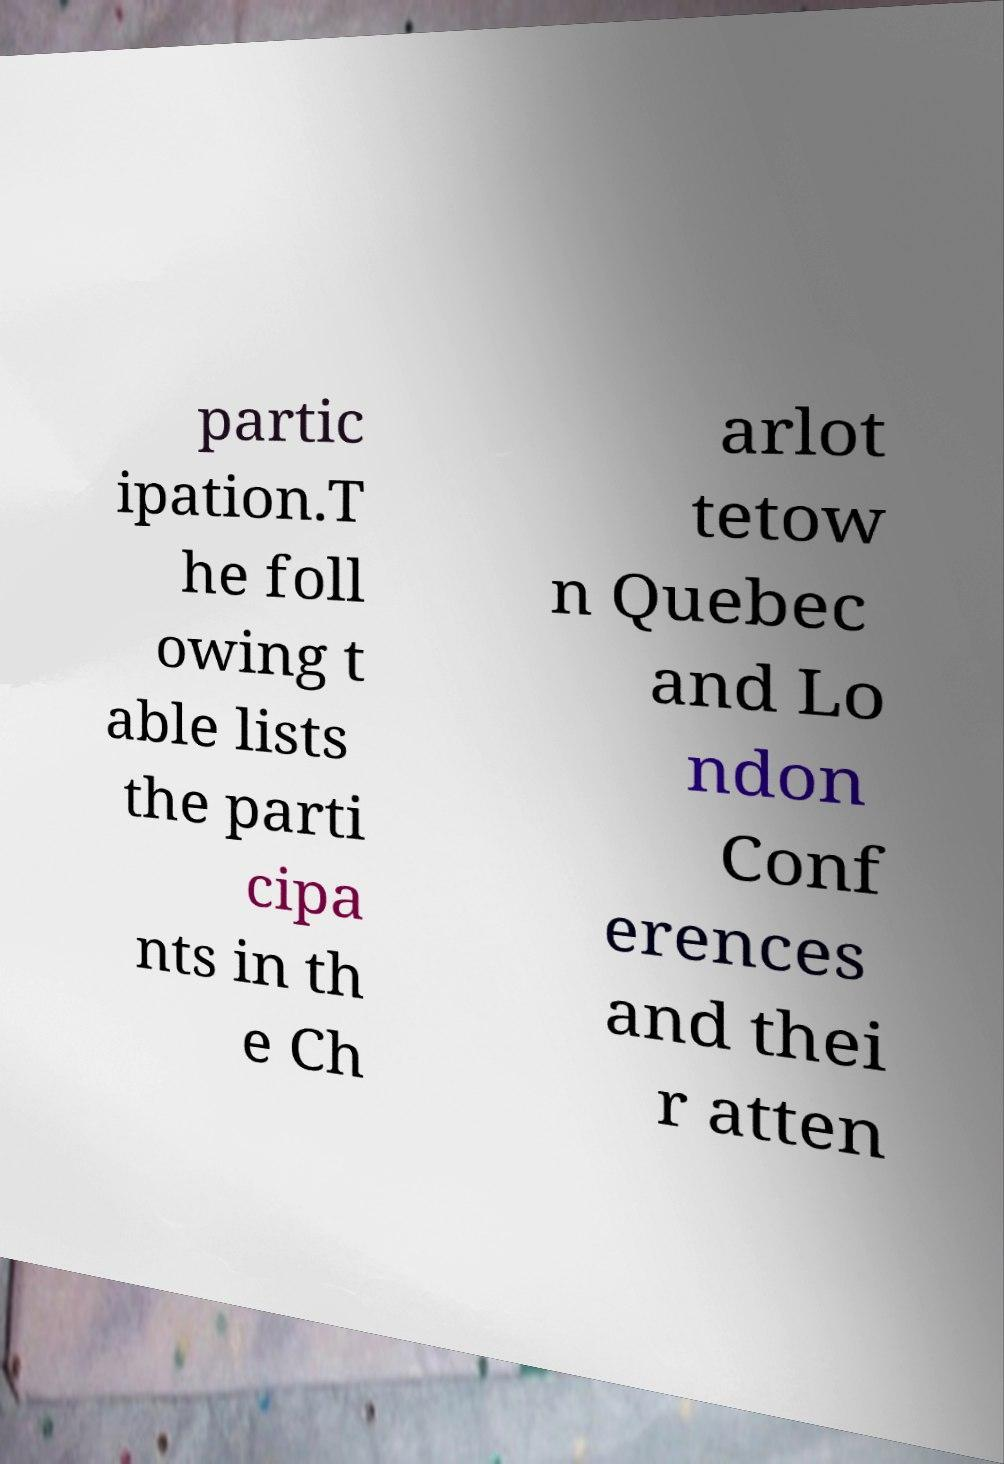Could you extract and type out the text from this image? partic ipation.T he foll owing t able lists the parti cipa nts in th e Ch arlot tetow n Quebec and Lo ndon Conf erences and thei r atten 